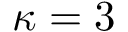<formula> <loc_0><loc_0><loc_500><loc_500>\kappa = 3</formula> 